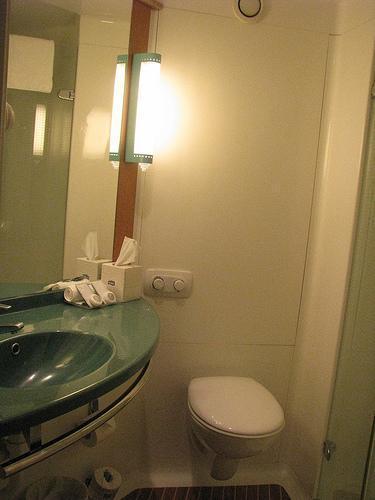How many toilets are visible?
Give a very brief answer. 1. 